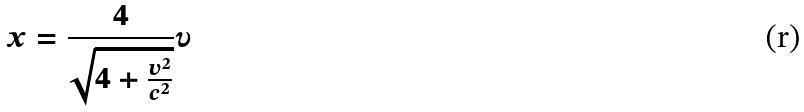Convert formula to latex. <formula><loc_0><loc_0><loc_500><loc_500>x = \frac { 4 } { \sqrt { 4 + \frac { v ^ { 2 } } { c ^ { 2 } } } } \upsilon</formula> 